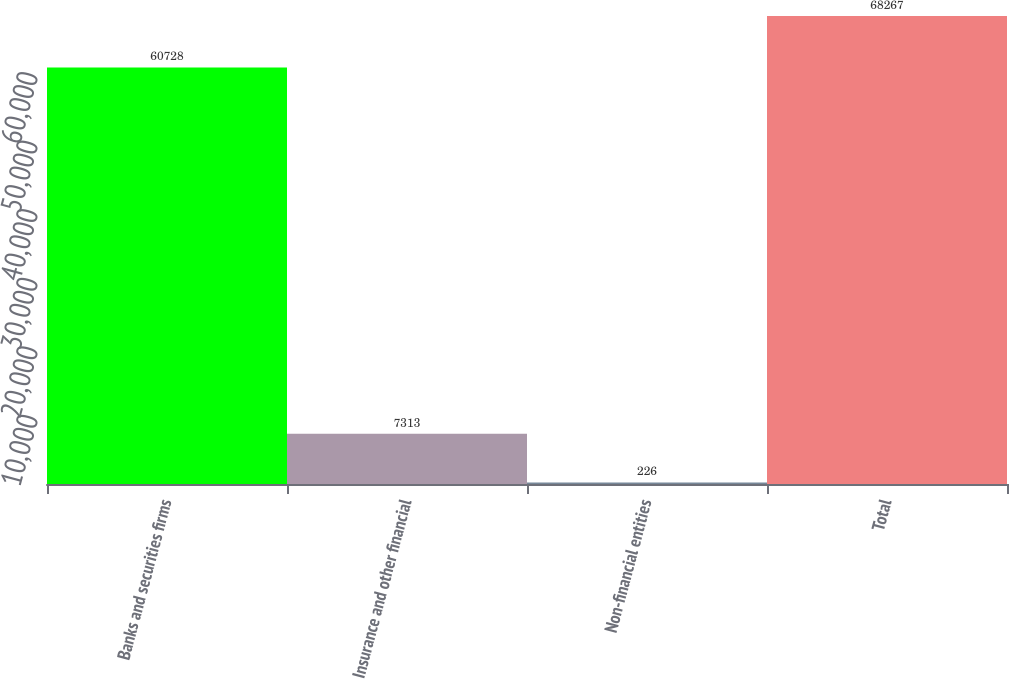Convert chart to OTSL. <chart><loc_0><loc_0><loc_500><loc_500><bar_chart><fcel>Banks and securities firms<fcel>Insurance and other financial<fcel>Non-financial entities<fcel>Total<nl><fcel>60728<fcel>7313<fcel>226<fcel>68267<nl></chart> 